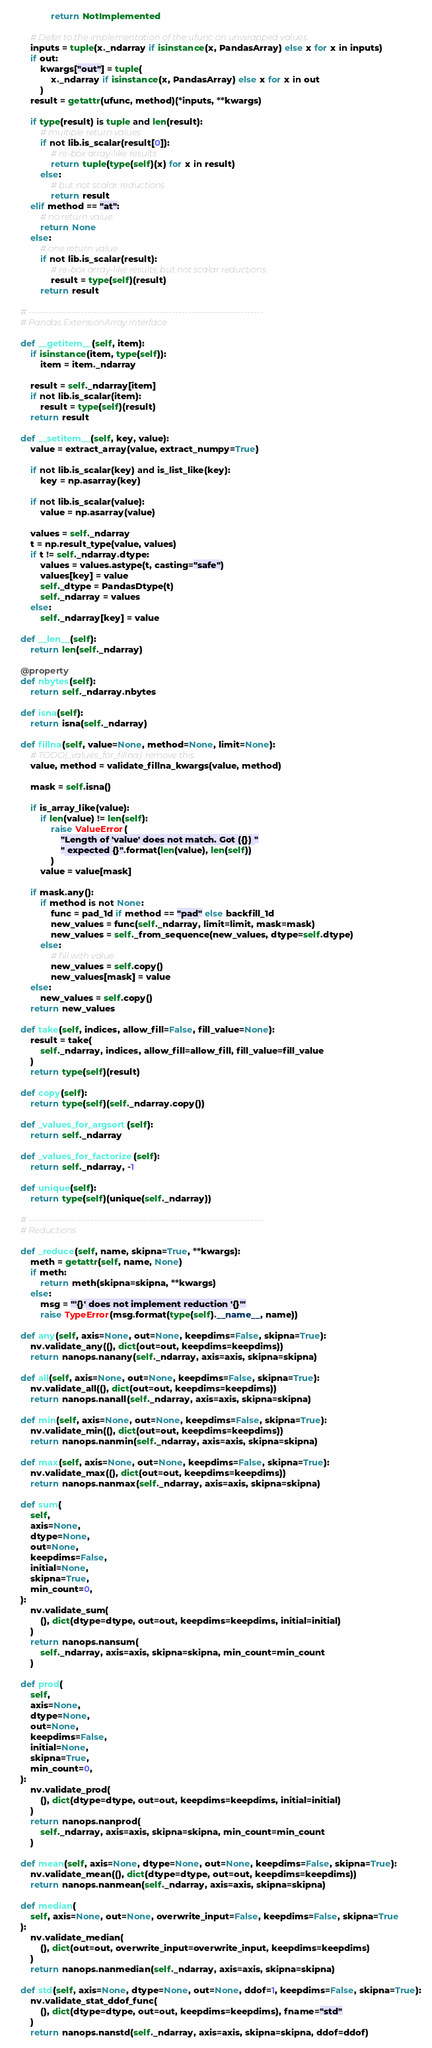Convert code to text. <code><loc_0><loc_0><loc_500><loc_500><_Python_>                return NotImplemented

        # Defer to the implementation of the ufunc on unwrapped values.
        inputs = tuple(x._ndarray if isinstance(x, PandasArray) else x for x in inputs)
        if out:
            kwargs["out"] = tuple(
                x._ndarray if isinstance(x, PandasArray) else x for x in out
            )
        result = getattr(ufunc, method)(*inputs, **kwargs)

        if type(result) is tuple and len(result):
            # multiple return values
            if not lib.is_scalar(result[0]):
                # re-box array-like results
                return tuple(type(self)(x) for x in result)
            else:
                # but not scalar reductions
                return result
        elif method == "at":
            # no return value
            return None
        else:
            # one return value
            if not lib.is_scalar(result):
                # re-box array-like results, but not scalar reductions
                result = type(self)(result)
            return result

    # ------------------------------------------------------------------------
    # Pandas ExtensionArray Interface

    def __getitem__(self, item):
        if isinstance(item, type(self)):
            item = item._ndarray

        result = self._ndarray[item]
        if not lib.is_scalar(item):
            result = type(self)(result)
        return result

    def __setitem__(self, key, value):
        value = extract_array(value, extract_numpy=True)

        if not lib.is_scalar(key) and is_list_like(key):
            key = np.asarray(key)

        if not lib.is_scalar(value):
            value = np.asarray(value)

        values = self._ndarray
        t = np.result_type(value, values)
        if t != self._ndarray.dtype:
            values = values.astype(t, casting="safe")
            values[key] = value
            self._dtype = PandasDtype(t)
            self._ndarray = values
        else:
            self._ndarray[key] = value

    def __len__(self):
        return len(self._ndarray)

    @property
    def nbytes(self):
        return self._ndarray.nbytes

    def isna(self):
        return isna(self._ndarray)

    def fillna(self, value=None, method=None, limit=None):
        # TODO(_values_for_fillna): remove this
        value, method = validate_fillna_kwargs(value, method)

        mask = self.isna()

        if is_array_like(value):
            if len(value) != len(self):
                raise ValueError(
                    "Length of 'value' does not match. Got ({}) "
                    " expected {}".format(len(value), len(self))
                )
            value = value[mask]

        if mask.any():
            if method is not None:
                func = pad_1d if method == "pad" else backfill_1d
                new_values = func(self._ndarray, limit=limit, mask=mask)
                new_values = self._from_sequence(new_values, dtype=self.dtype)
            else:
                # fill with value
                new_values = self.copy()
                new_values[mask] = value
        else:
            new_values = self.copy()
        return new_values

    def take(self, indices, allow_fill=False, fill_value=None):
        result = take(
            self._ndarray, indices, allow_fill=allow_fill, fill_value=fill_value
        )
        return type(self)(result)

    def copy(self):
        return type(self)(self._ndarray.copy())

    def _values_for_argsort(self):
        return self._ndarray

    def _values_for_factorize(self):
        return self._ndarray, -1

    def unique(self):
        return type(self)(unique(self._ndarray))

    # ------------------------------------------------------------------------
    # Reductions

    def _reduce(self, name, skipna=True, **kwargs):
        meth = getattr(self, name, None)
        if meth:
            return meth(skipna=skipna, **kwargs)
        else:
            msg = "'{}' does not implement reduction '{}'"
            raise TypeError(msg.format(type(self).__name__, name))

    def any(self, axis=None, out=None, keepdims=False, skipna=True):
        nv.validate_any((), dict(out=out, keepdims=keepdims))
        return nanops.nanany(self._ndarray, axis=axis, skipna=skipna)

    def all(self, axis=None, out=None, keepdims=False, skipna=True):
        nv.validate_all((), dict(out=out, keepdims=keepdims))
        return nanops.nanall(self._ndarray, axis=axis, skipna=skipna)

    def min(self, axis=None, out=None, keepdims=False, skipna=True):
        nv.validate_min((), dict(out=out, keepdims=keepdims))
        return nanops.nanmin(self._ndarray, axis=axis, skipna=skipna)

    def max(self, axis=None, out=None, keepdims=False, skipna=True):
        nv.validate_max((), dict(out=out, keepdims=keepdims))
        return nanops.nanmax(self._ndarray, axis=axis, skipna=skipna)

    def sum(
        self,
        axis=None,
        dtype=None,
        out=None,
        keepdims=False,
        initial=None,
        skipna=True,
        min_count=0,
    ):
        nv.validate_sum(
            (), dict(dtype=dtype, out=out, keepdims=keepdims, initial=initial)
        )
        return nanops.nansum(
            self._ndarray, axis=axis, skipna=skipna, min_count=min_count
        )

    def prod(
        self,
        axis=None,
        dtype=None,
        out=None,
        keepdims=False,
        initial=None,
        skipna=True,
        min_count=0,
    ):
        nv.validate_prod(
            (), dict(dtype=dtype, out=out, keepdims=keepdims, initial=initial)
        )
        return nanops.nanprod(
            self._ndarray, axis=axis, skipna=skipna, min_count=min_count
        )

    def mean(self, axis=None, dtype=None, out=None, keepdims=False, skipna=True):
        nv.validate_mean((), dict(dtype=dtype, out=out, keepdims=keepdims))
        return nanops.nanmean(self._ndarray, axis=axis, skipna=skipna)

    def median(
        self, axis=None, out=None, overwrite_input=False, keepdims=False, skipna=True
    ):
        nv.validate_median(
            (), dict(out=out, overwrite_input=overwrite_input, keepdims=keepdims)
        )
        return nanops.nanmedian(self._ndarray, axis=axis, skipna=skipna)

    def std(self, axis=None, dtype=None, out=None, ddof=1, keepdims=False, skipna=True):
        nv.validate_stat_ddof_func(
            (), dict(dtype=dtype, out=out, keepdims=keepdims), fname="std"
        )
        return nanops.nanstd(self._ndarray, axis=axis, skipna=skipna, ddof=ddof)
</code> 